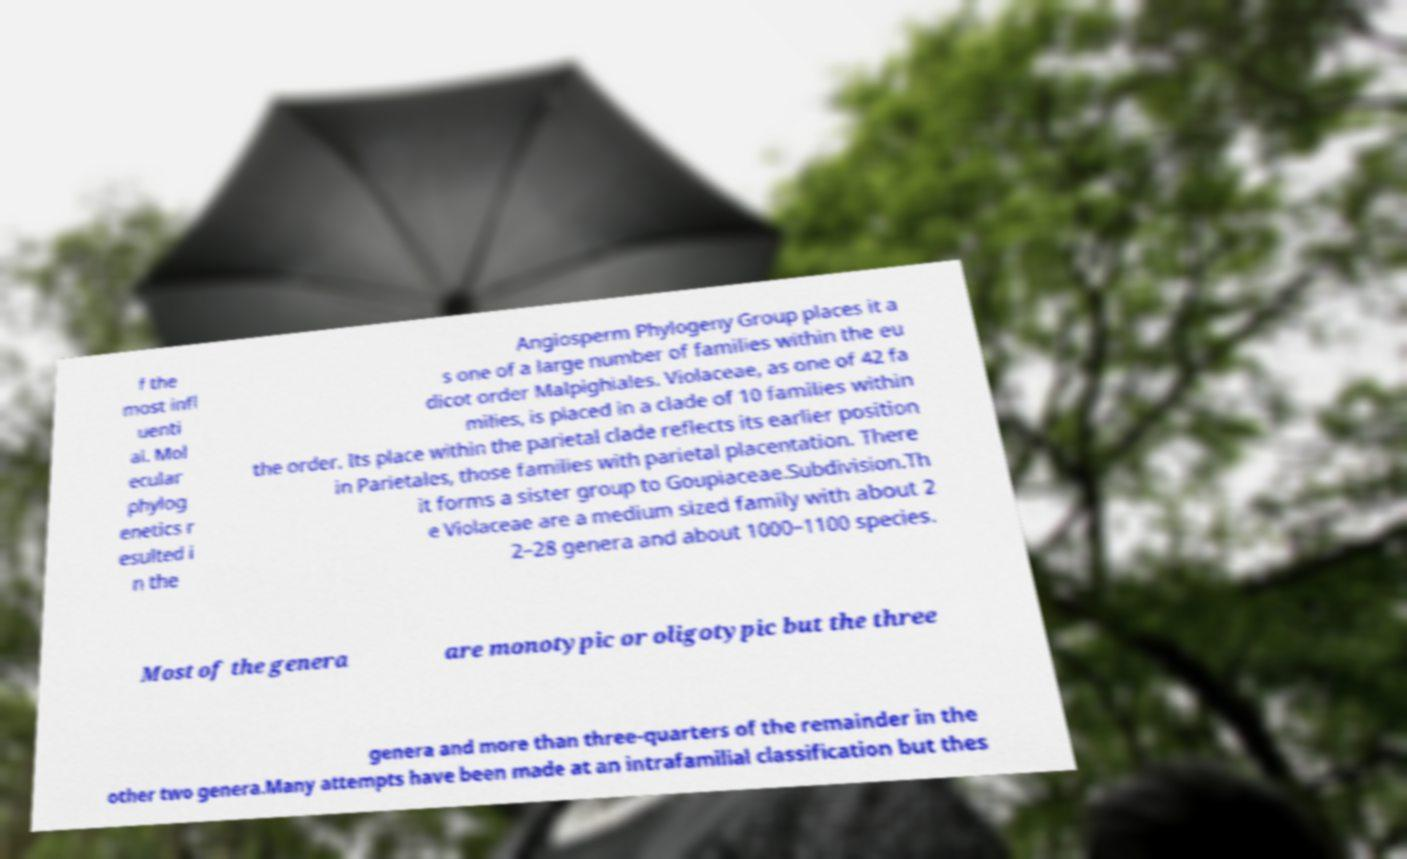There's text embedded in this image that I need extracted. Can you transcribe it verbatim? f the most infl uenti al. Mol ecular phylog enetics r esulted i n the Angiosperm Phylogeny Group places it a s one of a large number of families within the eu dicot order Malpighiales. Violaceae, as one of 42 fa milies, is placed in a clade of 10 families within the order. Its place within the parietal clade reflects its earlier position in Parietales, those families with parietal placentation. There it forms a sister group to Goupiaceae.Subdivision.Th e Violaceae are a medium sized family with about 2 2–28 genera and about 1000–1100 species. Most of the genera are monotypic or oligotypic but the three genera and more than three-quarters of the remainder in the other two genera.Many attempts have been made at an intrafamilial classification but thes 